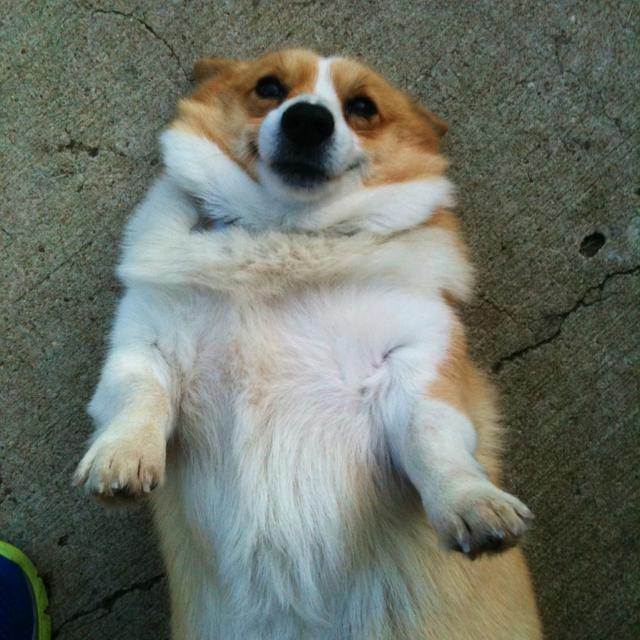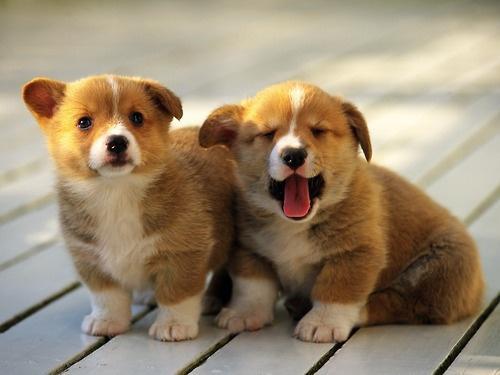The first image is the image on the left, the second image is the image on the right. For the images shown, is this caption "One image contains two dogs, sitting on a wooden slat deck or floor, while no image in the set contains green grass." true? Answer yes or no. Yes. The first image is the image on the left, the second image is the image on the right. Assess this claim about the two images: "There is at least three dogs.". Correct or not? Answer yes or no. Yes. 